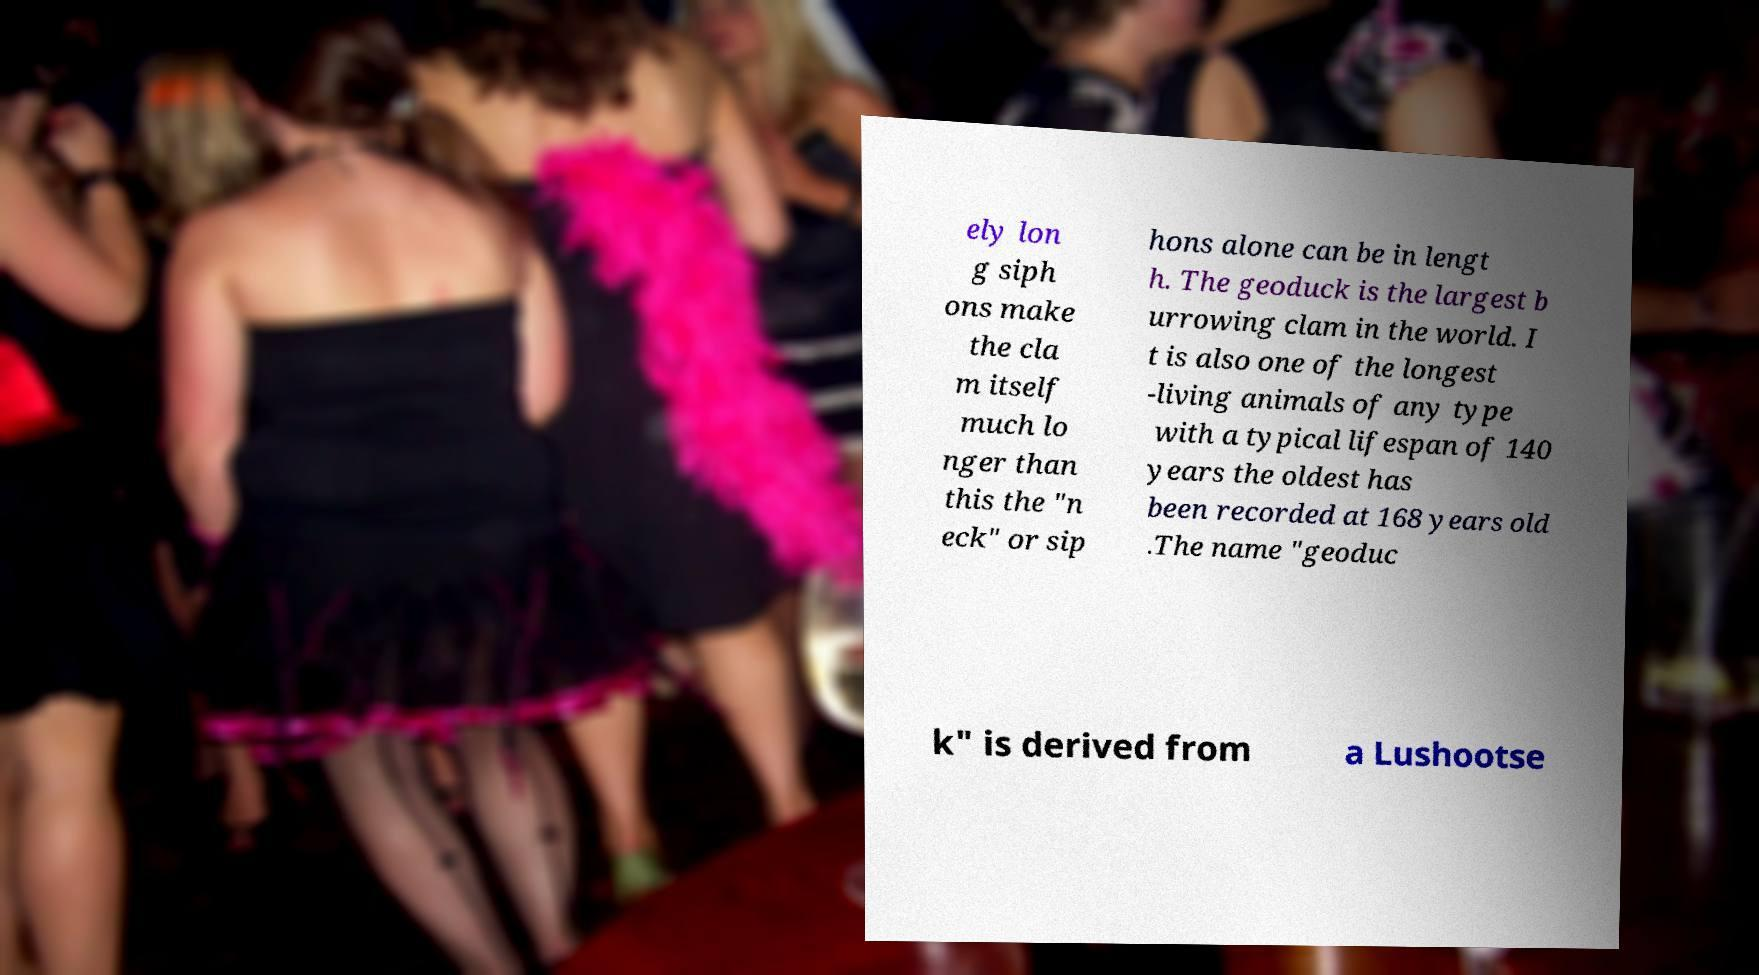Can you accurately transcribe the text from the provided image for me? ely lon g siph ons make the cla m itself much lo nger than this the "n eck" or sip hons alone can be in lengt h. The geoduck is the largest b urrowing clam in the world. I t is also one of the longest -living animals of any type with a typical lifespan of 140 years the oldest has been recorded at 168 years old .The name "geoduc k" is derived from a Lushootse 